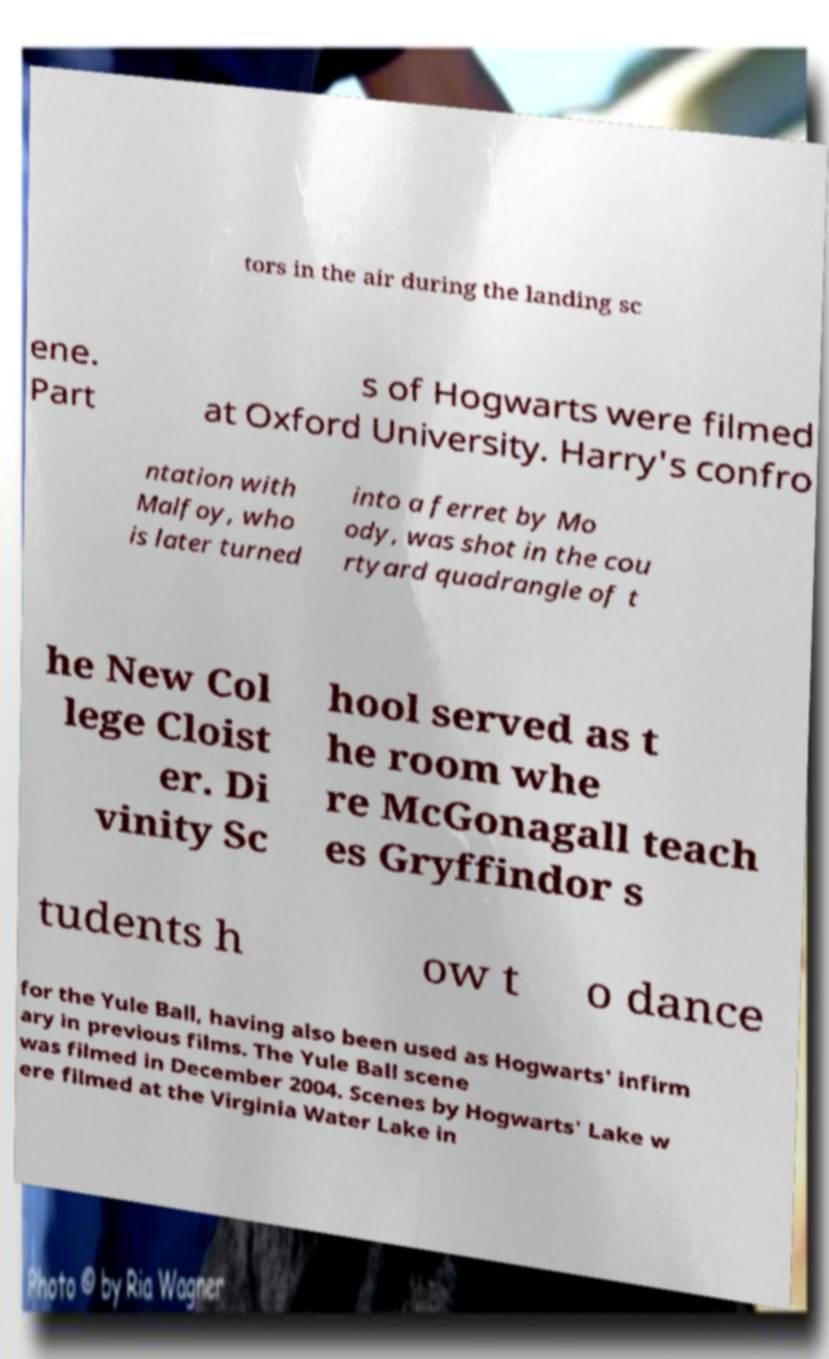What messages or text are displayed in this image? I need them in a readable, typed format. tors in the air during the landing sc ene. Part s of Hogwarts were filmed at Oxford University. Harry's confro ntation with Malfoy, who is later turned into a ferret by Mo ody, was shot in the cou rtyard quadrangle of t he New Col lege Cloist er. Di vinity Sc hool served as t he room whe re McGonagall teach es Gryffindor s tudents h ow t o dance for the Yule Ball, having also been used as Hogwarts' infirm ary in previous films. The Yule Ball scene was filmed in December 2004. Scenes by Hogwarts' Lake w ere filmed at the Virginia Water Lake in 